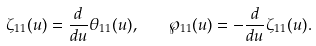Convert formula to latex. <formula><loc_0><loc_0><loc_500><loc_500>\zeta _ { 1 1 } ( u ) = \frac { d } { d u } \theta _ { 1 1 } ( u ) , \quad \wp _ { 1 1 } ( u ) = - \frac { d } { d u } \zeta _ { 1 1 } ( u ) .</formula> 